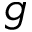<formula> <loc_0><loc_0><loc_500><loc_500>g</formula> 